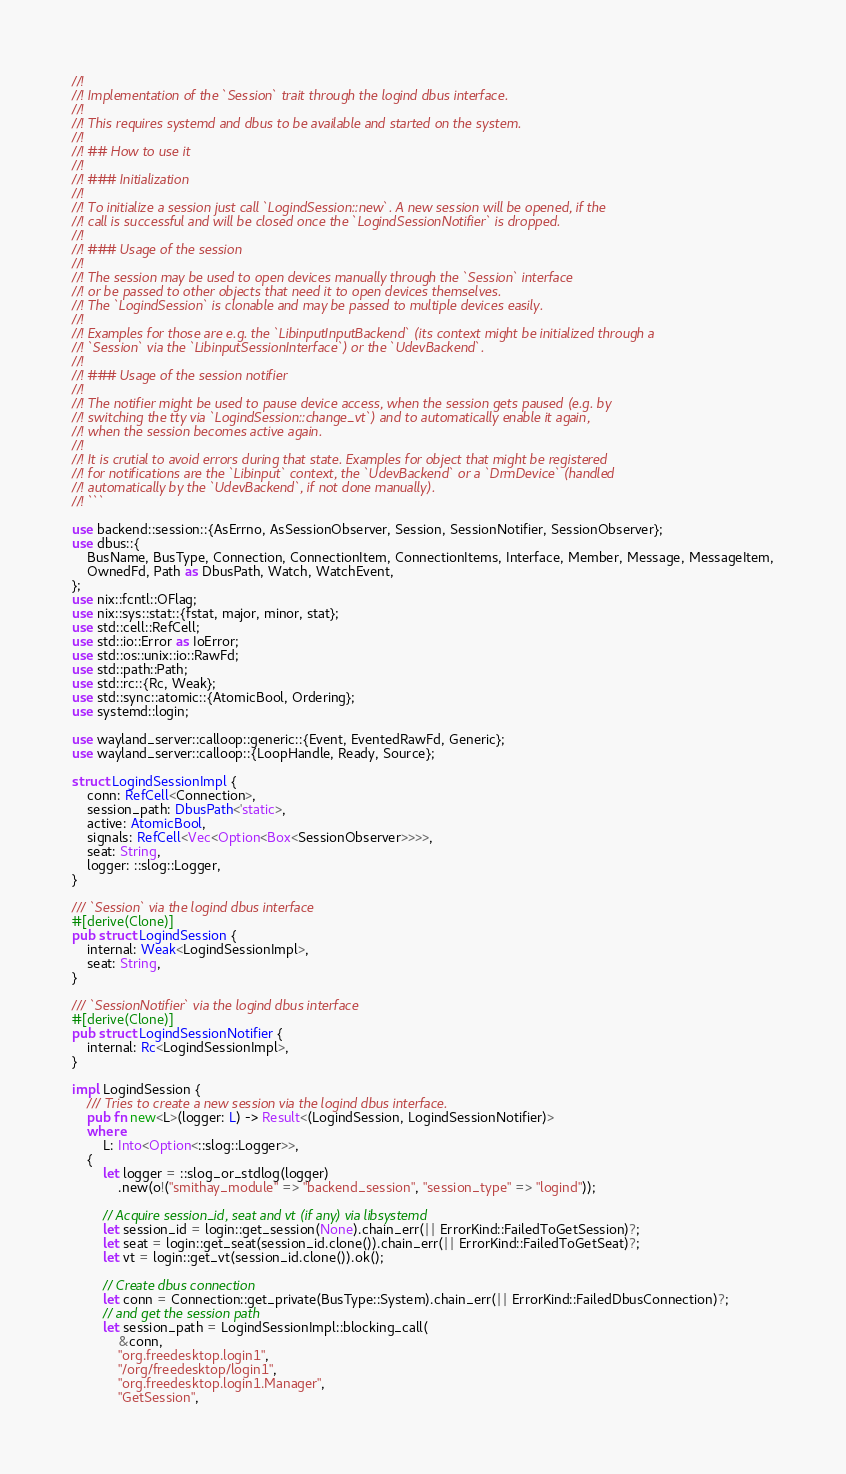Convert code to text. <code><loc_0><loc_0><loc_500><loc_500><_Rust_>//!
//! Implementation of the `Session` trait through the logind dbus interface.
//!
//! This requires systemd and dbus to be available and started on the system.
//!
//! ## How to use it
//!
//! ### Initialization
//!
//! To initialize a session just call `LogindSession::new`. A new session will be opened, if the
//! call is successful and will be closed once the `LogindSessionNotifier` is dropped.
//!
//! ### Usage of the session
//!
//! The session may be used to open devices manually through the `Session` interface
//! or be passed to other objects that need it to open devices themselves.
//! The `LogindSession` is clonable and may be passed to multiple devices easily.
//!
//! Examples for those are e.g. the `LibinputInputBackend` (its context might be initialized through a
//! `Session` via the `LibinputSessionInterface`) or the `UdevBackend`.
//!
//! ### Usage of the session notifier
//!
//! The notifier might be used to pause device access, when the session gets paused (e.g. by
//! switching the tty via `LogindSession::change_vt`) and to automatically enable it again,
//! when the session becomes active again.
//!
//! It is crutial to avoid errors during that state. Examples for object that might be registered
//! for notifications are the `Libinput` context, the `UdevBackend` or a `DrmDevice` (handled
//! automatically by the `UdevBackend`, if not done manually).
//! ```

use backend::session::{AsErrno, AsSessionObserver, Session, SessionNotifier, SessionObserver};
use dbus::{
    BusName, BusType, Connection, ConnectionItem, ConnectionItems, Interface, Member, Message, MessageItem,
    OwnedFd, Path as DbusPath, Watch, WatchEvent,
};
use nix::fcntl::OFlag;
use nix::sys::stat::{fstat, major, minor, stat};
use std::cell::RefCell;
use std::io::Error as IoError;
use std::os::unix::io::RawFd;
use std::path::Path;
use std::rc::{Rc, Weak};
use std::sync::atomic::{AtomicBool, Ordering};
use systemd::login;

use wayland_server::calloop::generic::{Event, EventedRawFd, Generic};
use wayland_server::calloop::{LoopHandle, Ready, Source};

struct LogindSessionImpl {
    conn: RefCell<Connection>,
    session_path: DbusPath<'static>,
    active: AtomicBool,
    signals: RefCell<Vec<Option<Box<SessionObserver>>>>,
    seat: String,
    logger: ::slog::Logger,
}

/// `Session` via the logind dbus interface
#[derive(Clone)]
pub struct LogindSession {
    internal: Weak<LogindSessionImpl>,
    seat: String,
}

/// `SessionNotifier` via the logind dbus interface
#[derive(Clone)]
pub struct LogindSessionNotifier {
    internal: Rc<LogindSessionImpl>,
}

impl LogindSession {
    /// Tries to create a new session via the logind dbus interface.
    pub fn new<L>(logger: L) -> Result<(LogindSession, LogindSessionNotifier)>
    where
        L: Into<Option<::slog::Logger>>,
    {
        let logger = ::slog_or_stdlog(logger)
            .new(o!("smithay_module" => "backend_session", "session_type" => "logind"));

        // Acquire session_id, seat and vt (if any) via libsystemd
        let session_id = login::get_session(None).chain_err(|| ErrorKind::FailedToGetSession)?;
        let seat = login::get_seat(session_id.clone()).chain_err(|| ErrorKind::FailedToGetSeat)?;
        let vt = login::get_vt(session_id.clone()).ok();

        // Create dbus connection
        let conn = Connection::get_private(BusType::System).chain_err(|| ErrorKind::FailedDbusConnection)?;
        // and get the session path
        let session_path = LogindSessionImpl::blocking_call(
            &conn,
            "org.freedesktop.login1",
            "/org/freedesktop/login1",
            "org.freedesktop.login1.Manager",
            "GetSession",</code> 